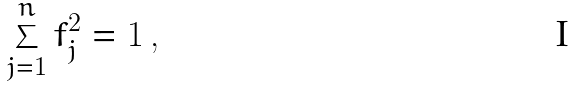Convert formula to latex. <formula><loc_0><loc_0><loc_500><loc_500>\sum _ { j = 1 } ^ { n } f _ { j } ^ { 2 } = 1 \, ,</formula> 